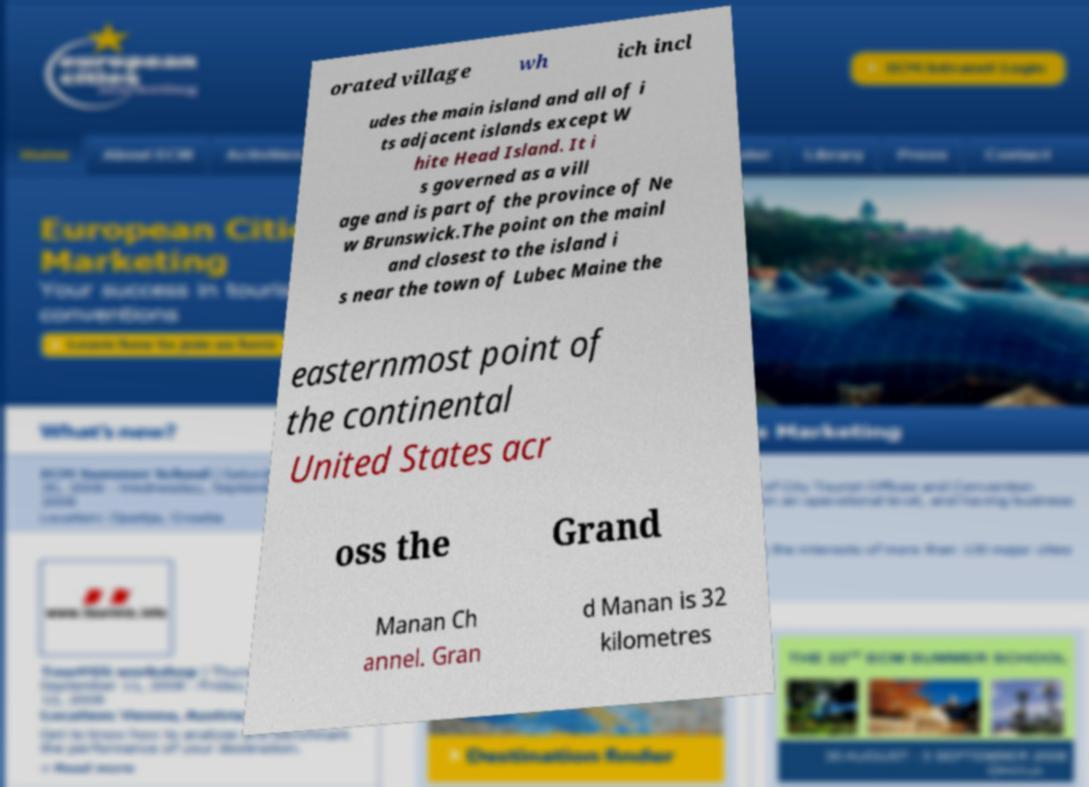Please identify and transcribe the text found in this image. orated village wh ich incl udes the main island and all of i ts adjacent islands except W hite Head Island. It i s governed as a vill age and is part of the province of Ne w Brunswick.The point on the mainl and closest to the island i s near the town of Lubec Maine the easternmost point of the continental United States acr oss the Grand Manan Ch annel. Gran d Manan is 32 kilometres 